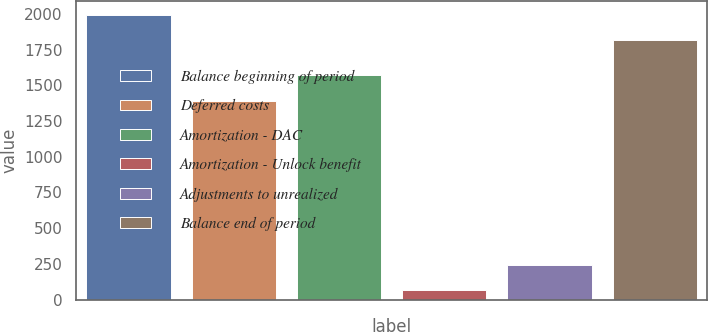<chart> <loc_0><loc_0><loc_500><loc_500><bar_chart><fcel>Balance beginning of period<fcel>Deferred costs<fcel>Amortization - DAC<fcel>Amortization - Unlock benefit<fcel>Adjustments to unrealized<fcel>Balance end of period<nl><fcel>1991.4<fcel>1390<fcel>1571<fcel>69<fcel>244.4<fcel>1816<nl></chart> 